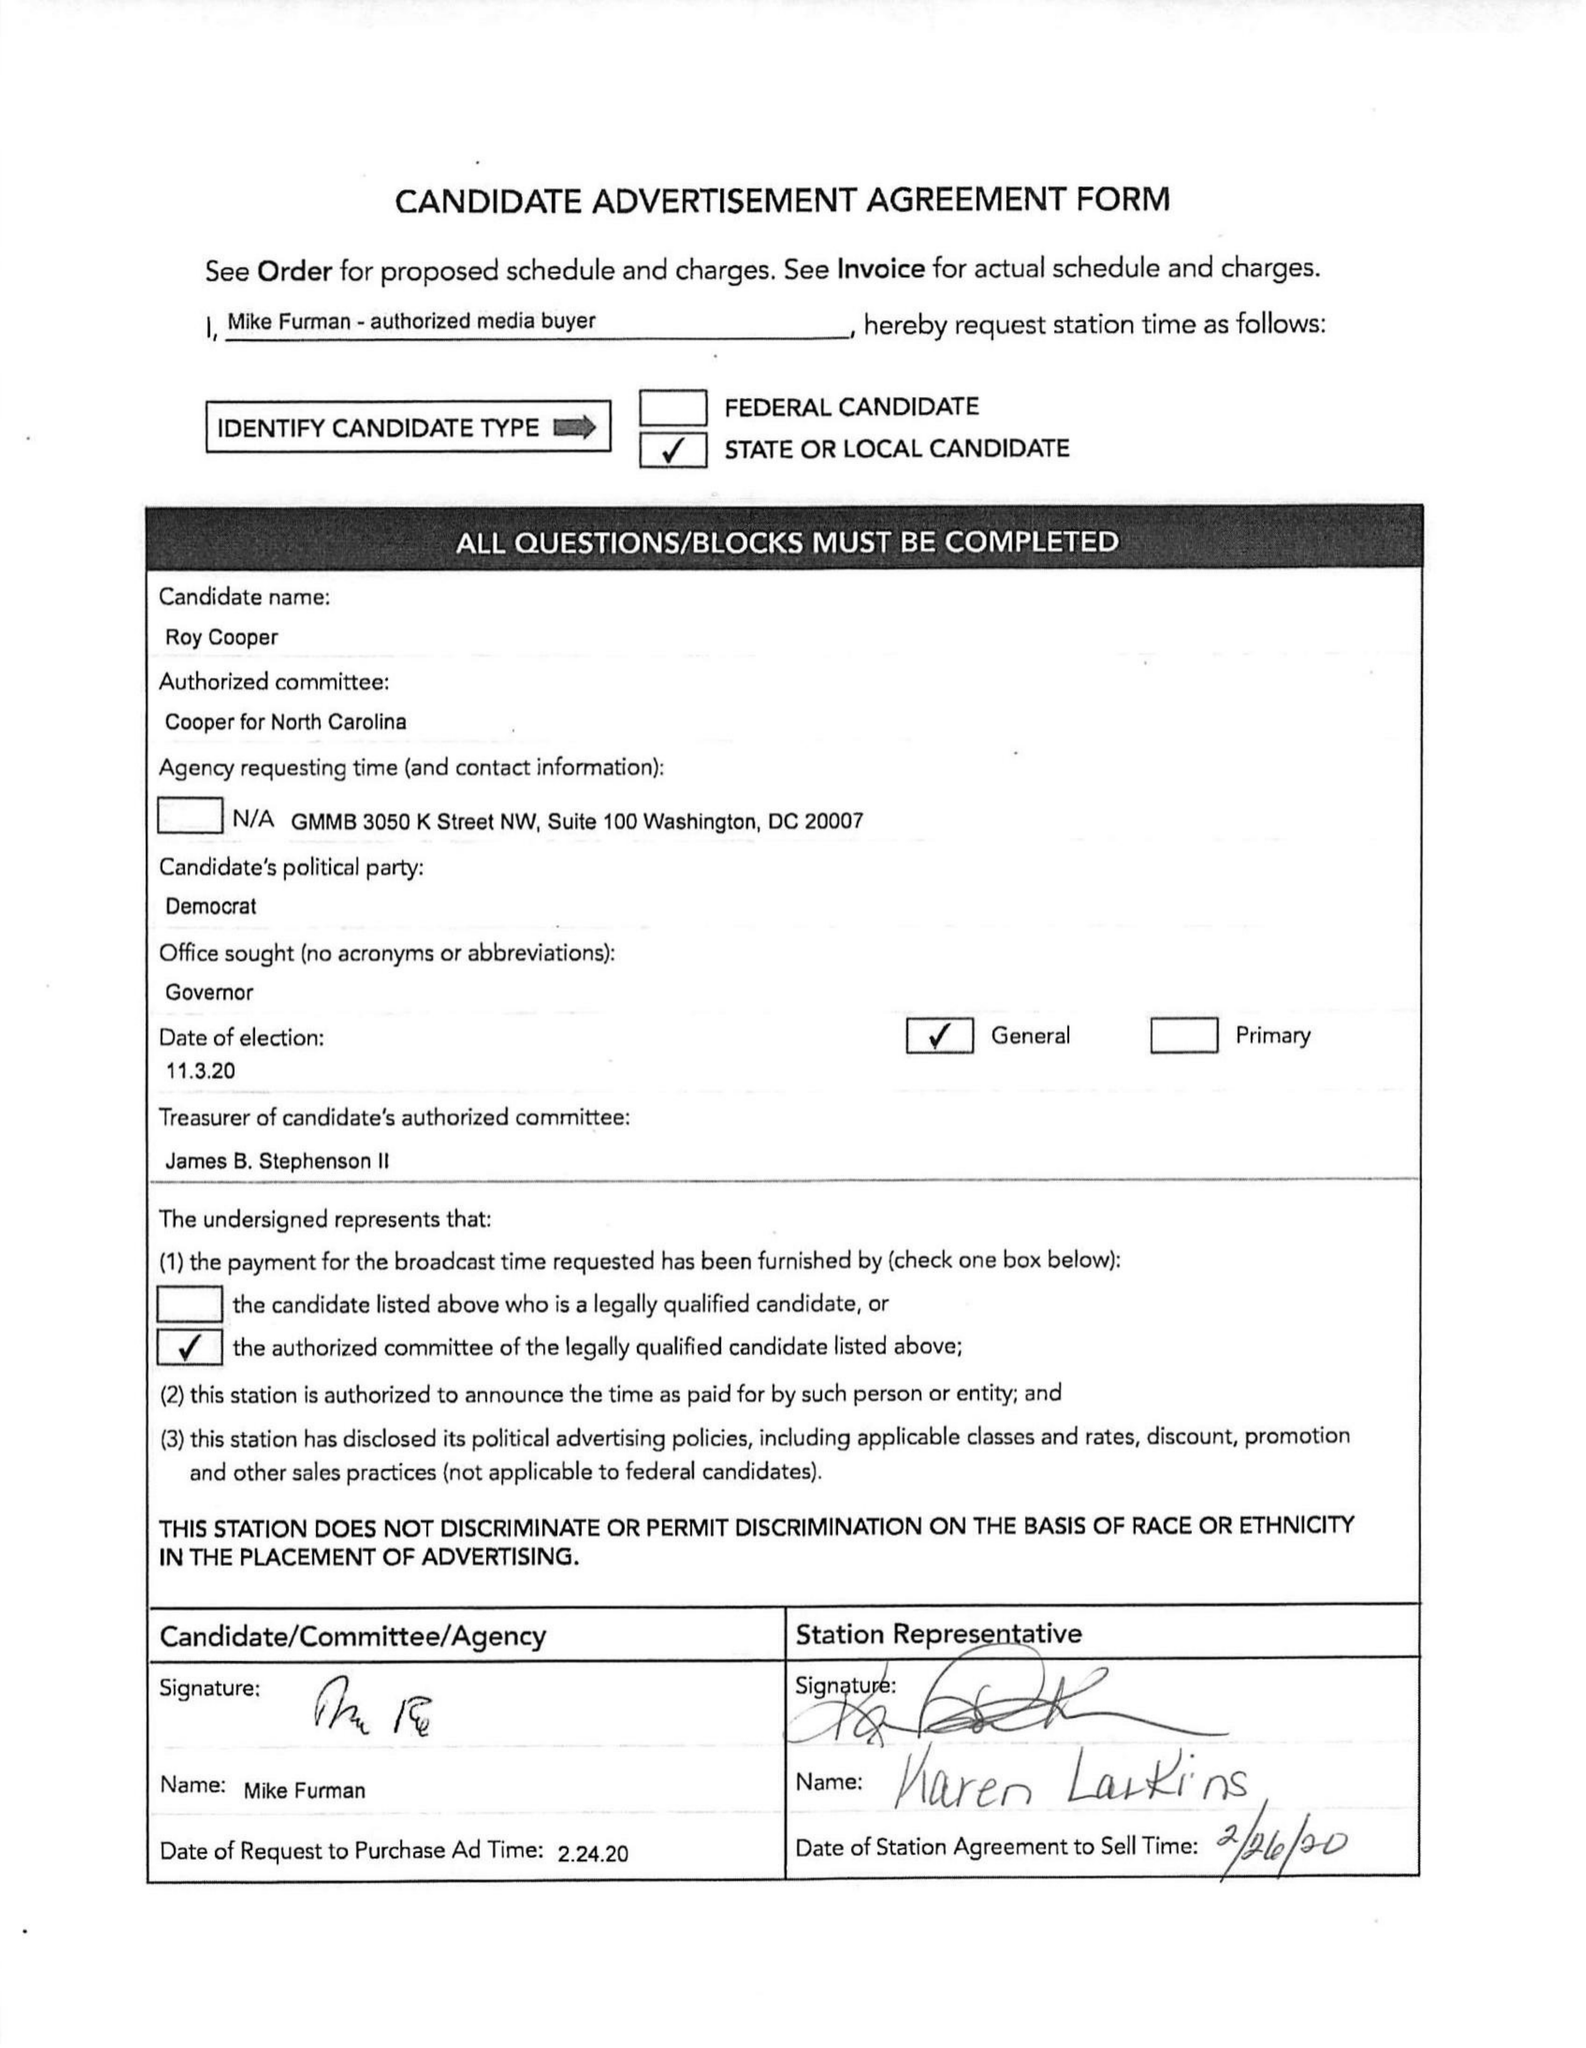What is the value for the advertiser?
Answer the question using a single word or phrase. ROY COOPER FOR GOVERNOR 